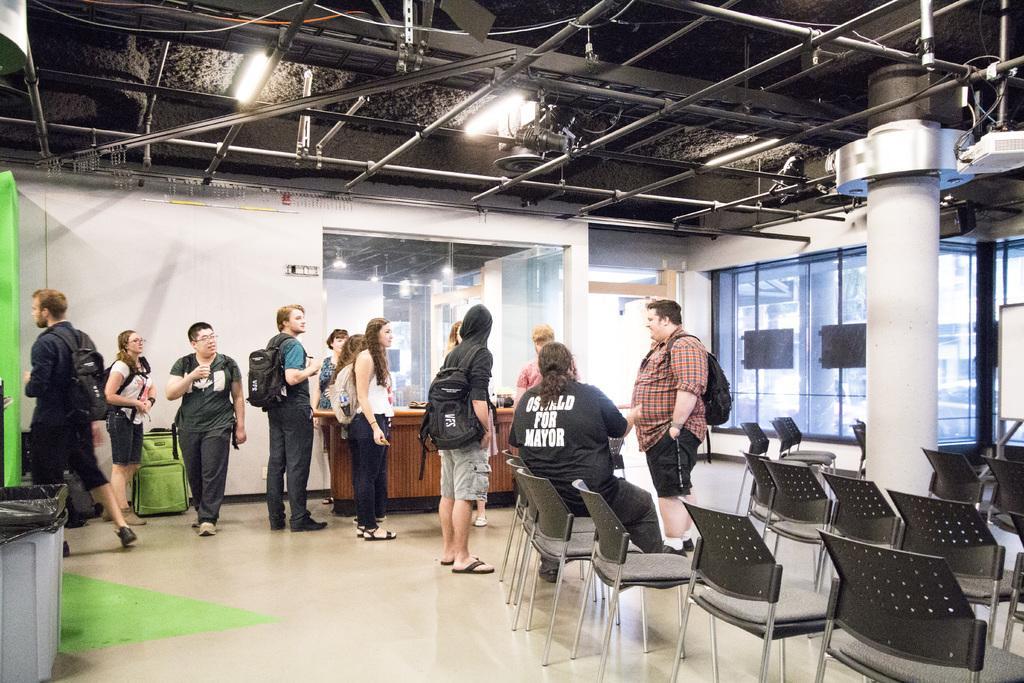In one or two sentences, can you explain what this image depicts? This picture describes about group of people few are seated on the chair and few are standing, and few people are wearing backpacks, in the left side of the given image we can find a dustbin, on top of them we can see couple of metal rods and lights. 